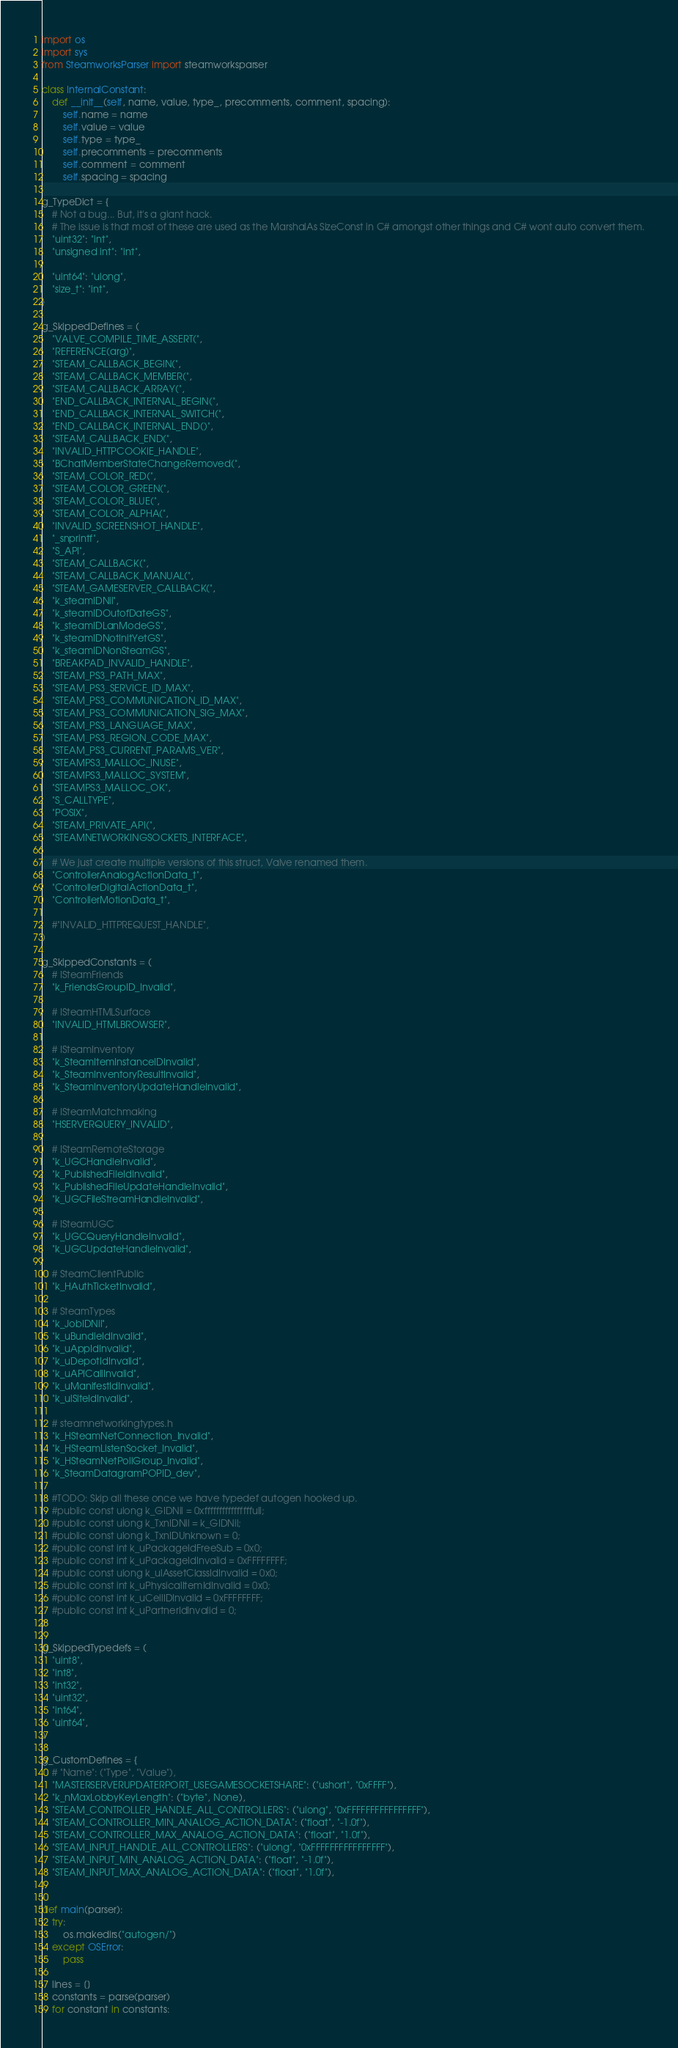Convert code to text. <code><loc_0><loc_0><loc_500><loc_500><_Python_>import os
import sys
from SteamworksParser import steamworksparser

class InternalConstant:
    def __init__(self, name, value, type_, precomments, comment, spacing):
        self.name = name
        self.value = value
        self.type = type_
        self.precomments = precomments
        self.comment = comment
        self.spacing = spacing

g_TypeDict = {
    # Not a bug... But, it's a giant hack.
    # The issue is that most of these are used as the MarshalAs SizeConst in C# amongst other things and C# wont auto convert them.
    "uint32": "int",
    "unsigned int": "int",

    "uint64": "ulong",
    "size_t": "int",
}

g_SkippedDefines = (
    "VALVE_COMPILE_TIME_ASSERT(",
    "REFERENCE(arg)",
    "STEAM_CALLBACK_BEGIN(",
    "STEAM_CALLBACK_MEMBER(",
    "STEAM_CALLBACK_ARRAY(",
    "END_CALLBACK_INTERNAL_BEGIN(",
    "END_CALLBACK_INTERNAL_SWITCH(",
    "END_CALLBACK_INTERNAL_END()",
    "STEAM_CALLBACK_END(",
    "INVALID_HTTPCOOKIE_HANDLE",
    "BChatMemberStateChangeRemoved(",
    "STEAM_COLOR_RED(",
    "STEAM_COLOR_GREEN(",
    "STEAM_COLOR_BLUE(",
    "STEAM_COLOR_ALPHA(",
    "INVALID_SCREENSHOT_HANDLE",
    "_snprintf",
    "S_API",
    "STEAM_CALLBACK(",
    "STEAM_CALLBACK_MANUAL(",
    "STEAM_GAMESERVER_CALLBACK(",
    "k_steamIDNil",
    "k_steamIDOutofDateGS",
    "k_steamIDLanModeGS",
    "k_steamIDNotInitYetGS",
    "k_steamIDNonSteamGS",
    "BREAKPAD_INVALID_HANDLE",
    "STEAM_PS3_PATH_MAX",
    "STEAM_PS3_SERVICE_ID_MAX",
    "STEAM_PS3_COMMUNICATION_ID_MAX",
    "STEAM_PS3_COMMUNICATION_SIG_MAX",
    "STEAM_PS3_LANGUAGE_MAX",
    "STEAM_PS3_REGION_CODE_MAX",
    "STEAM_PS3_CURRENT_PARAMS_VER",
    "STEAMPS3_MALLOC_INUSE",
    "STEAMPS3_MALLOC_SYSTEM",
    "STEAMPS3_MALLOC_OK",
    "S_CALLTYPE",
    "POSIX",
    "STEAM_PRIVATE_API(",
    "STEAMNETWORKINGSOCKETS_INTERFACE",

    # We just create multiple versions of this struct, Valve renamed them.
    "ControllerAnalogActionData_t",
    "ControllerDigitalActionData_t",
    "ControllerMotionData_t",

    #"INVALID_HTTPREQUEST_HANDLE",
)

g_SkippedConstants = (
    # ISteamFriends
    "k_FriendsGroupID_Invalid",

    # ISteamHTMLSurface
    "INVALID_HTMLBROWSER",

    # ISteamInventory
    "k_SteamItemInstanceIDInvalid",
    "k_SteamInventoryResultInvalid",
    "k_SteamInventoryUpdateHandleInvalid",

    # ISteamMatchmaking
    "HSERVERQUERY_INVALID",

    # ISteamRemoteStorage
    "k_UGCHandleInvalid",
    "k_PublishedFileIdInvalid",
    "k_PublishedFileUpdateHandleInvalid",
    "k_UGCFileStreamHandleInvalid",

    # ISteamUGC
    "k_UGCQueryHandleInvalid",
    "k_UGCUpdateHandleInvalid",

    # SteamClientPublic
    "k_HAuthTicketInvalid",

    # SteamTypes
    "k_JobIDNil",
    "k_uBundleIdInvalid",
    "k_uAppIdInvalid",
    "k_uDepotIdInvalid",
    "k_uAPICallInvalid",
    "k_uManifestIdInvalid",
    "k_ulSiteIdInvalid",

    # steamnetworkingtypes.h
    "k_HSteamNetConnection_Invalid",
    "k_HSteamListenSocket_Invalid",
    "k_HSteamNetPollGroup_Invalid",
    "k_SteamDatagramPOPID_dev",

    #TODO: Skip all these once we have typedef autogen hooked up.
    #public const ulong k_GIDNil = 0xffffffffffffffffull;
    #public const ulong k_TxnIDNil = k_GIDNil;
    #public const ulong k_TxnIDUnknown = 0;
    #public const int k_uPackageIdFreeSub = 0x0;
    #public const int k_uPackageIdInvalid = 0xFFFFFFFF;
    #public const ulong k_ulAssetClassIdInvalid = 0x0;
    #public const int k_uPhysicalItemIdInvalid = 0x0;
    #public const int k_uCellIDInvalid = 0xFFFFFFFF;
    #public const int k_uPartnerIdInvalid = 0;
)

g_SkippedTypedefs = (
    "uint8",
    "int8",
    "int32",
    "uint32",
    "int64",
    "uint64",
)

g_CustomDefines = {
    # "Name": ("Type", "Value"),
    "MASTERSERVERUPDATERPORT_USEGAMESOCKETSHARE": ("ushort", "0xFFFF"),
    "k_nMaxLobbyKeyLength": ("byte", None),
    "STEAM_CONTROLLER_HANDLE_ALL_CONTROLLERS": ("ulong", "0xFFFFFFFFFFFFFFFF"),
    "STEAM_CONTROLLER_MIN_ANALOG_ACTION_DATA": ("float", "-1.0f"),
    "STEAM_CONTROLLER_MAX_ANALOG_ACTION_DATA": ("float", "1.0f"),
    "STEAM_INPUT_HANDLE_ALL_CONTROLLERS": ("ulong", "0xFFFFFFFFFFFFFFFF"),
    "STEAM_INPUT_MIN_ANALOG_ACTION_DATA": ("float", "-1.0f"),
    "STEAM_INPUT_MAX_ANALOG_ACTION_DATA": ("float", "1.0f"),
}

def main(parser):
    try:
        os.makedirs("autogen/")
    except OSError:
        pass

    lines = []
    constants = parse(parser)
    for constant in constants:</code> 